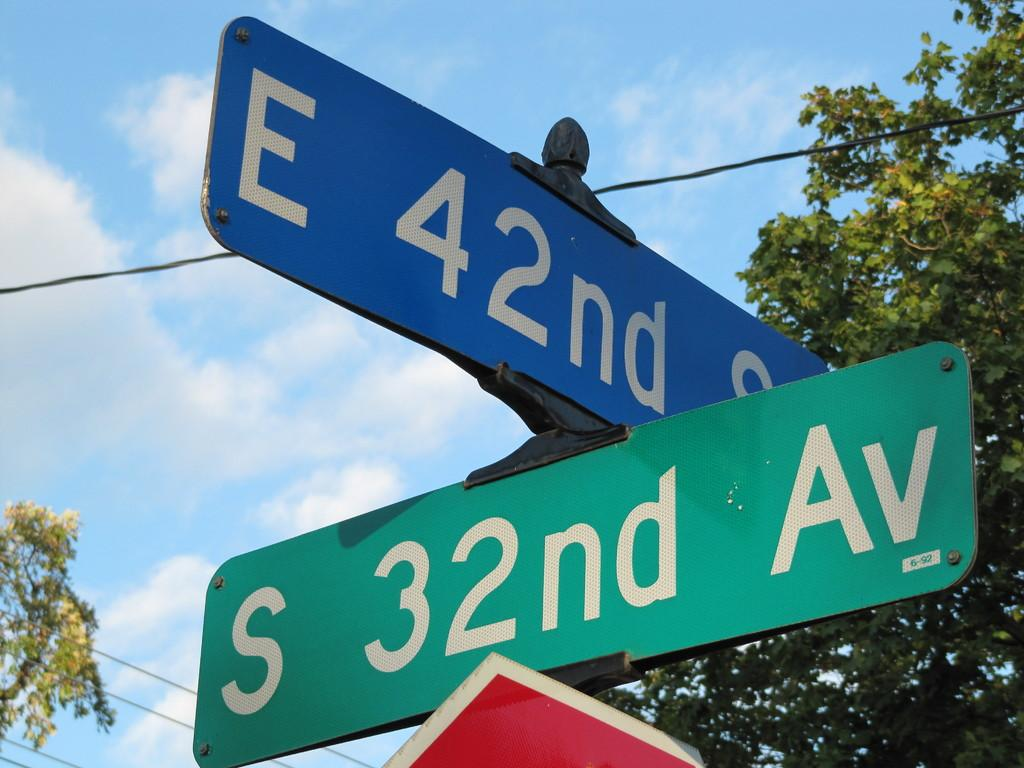What can be seen in the foreground of the image? There are three sign boards in the foreground of the image. What is visible in the background of the image? There is a group of trees and cables in the background of the image. What is the condition of the sky in the image? The sky is visible in the background of the image, and it appears to be cloudy. Is there a crowd of people fighting on a ship in the image? No, there is no crowd, fight, or ship present in the image. The image features three sign boards in the foreground, a group of trees and cables in the background, and a cloudy sky. 